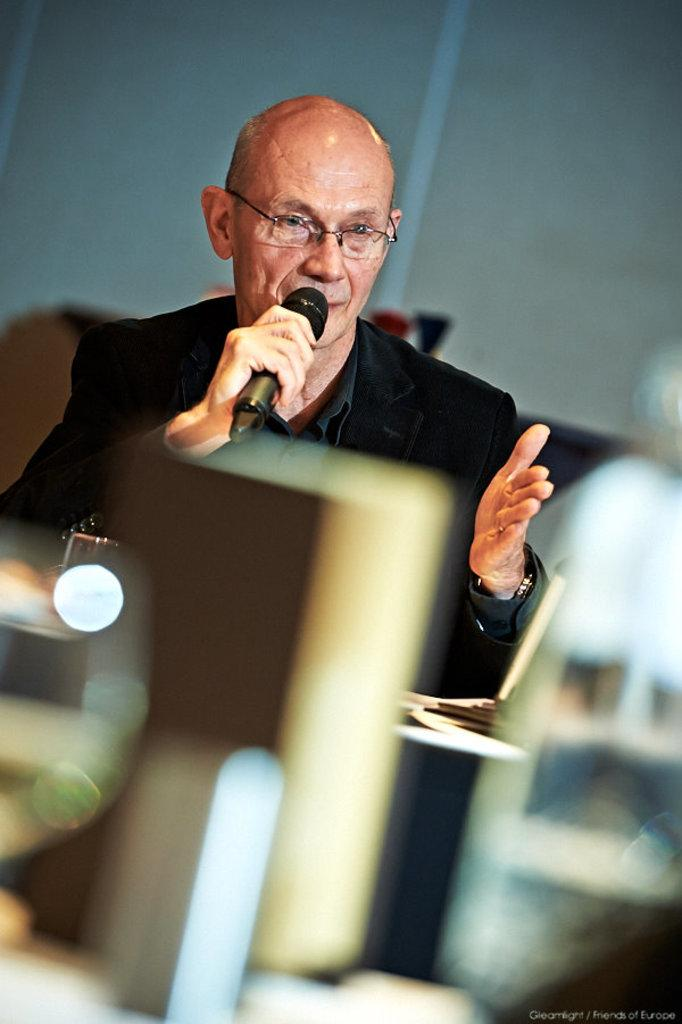Who or what is the main subject of the image? There is a person in the image. What is the person wearing? The person is wearing a black color jacket. Are there any accessories visible on the person? Yes, the person is wearing spectacles. What is the person holding in his hand? The person is holding a microphone in his hand. Is the person in the image trying to escape from quicksand? There is no quicksand present in the image, and the person is not attempting to escape from anything. 